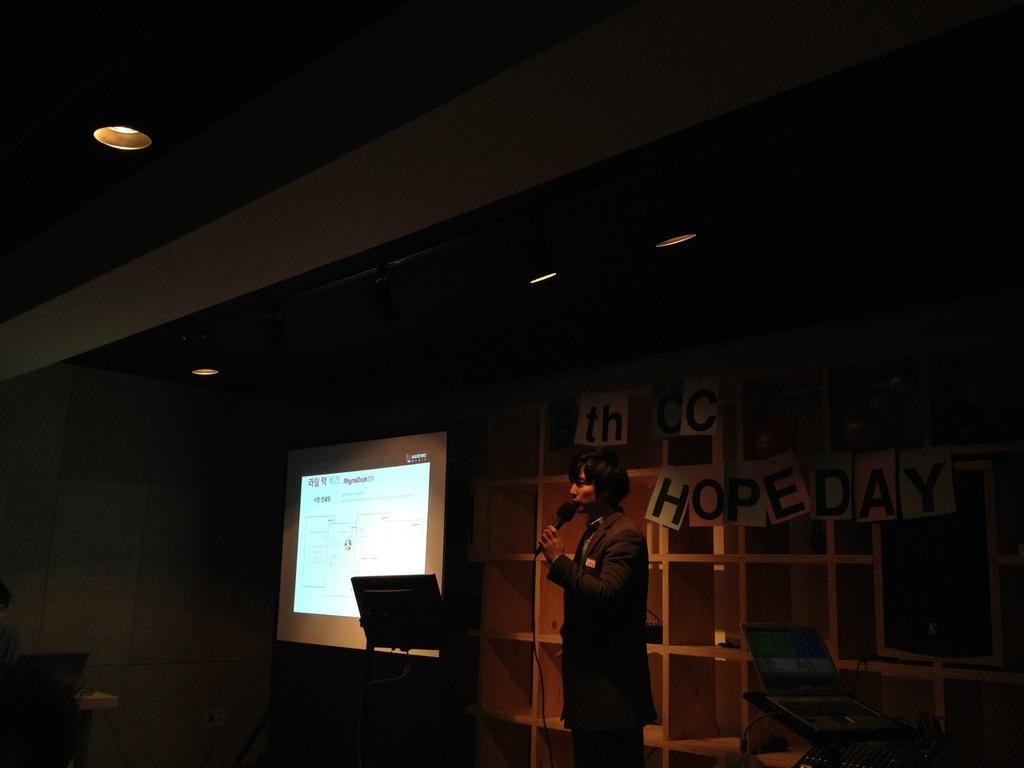What is the person in the image holding? The person is holding a microphone in the image. What can be seen in the background of the image? In the background of the image, there are racks, a screen, a wall, and posters. What type of lighting is visible in the image? There are lights visible in the image. What electronic device is present in the image? There is a laptop in the image. How many giants are visible in the image? There are no giants present in the image. What type of cent is shown interacting with the laptop in the image? There is no cent present in the image; only a person holding a microphone, lights, and a laptop are visible. 